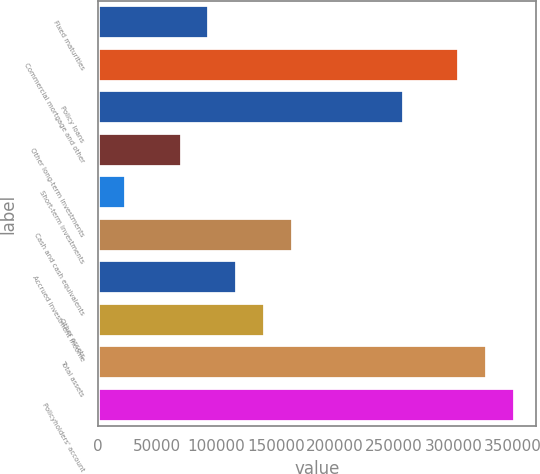Convert chart to OTSL. <chart><loc_0><loc_0><loc_500><loc_500><bar_chart><fcel>Fixed maturities<fcel>Commercial mortgage and other<fcel>Policy loans<fcel>Other long-term investments<fcel>Short-term investments<fcel>Cash and cash equivalents<fcel>Accrued investment income<fcel>Other assets<fcel>Total assets<fcel>Policyholders' account<nl><fcel>93819.1<fcel>304903<fcel>257996<fcel>70365.3<fcel>23457.7<fcel>164181<fcel>117273<fcel>140727<fcel>328357<fcel>351811<nl></chart> 